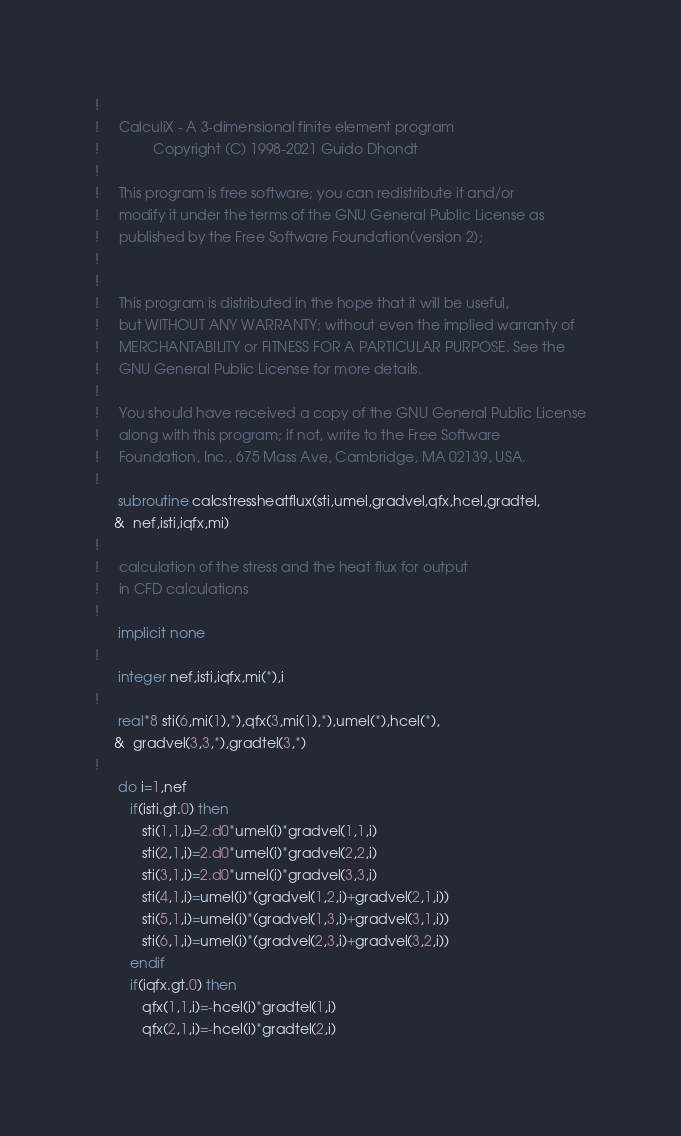Convert code to text. <code><loc_0><loc_0><loc_500><loc_500><_FORTRAN_>!
!     CalculiX - A 3-dimensional finite element program
!              Copyright (C) 1998-2021 Guido Dhondt
!
!     This program is free software; you can redistribute it and/or
!     modify it under the terms of the GNU General Public License as
!     published by the Free Software Foundation(version 2);
!     
!
!     This program is distributed in the hope that it will be useful,
!     but WITHOUT ANY WARRANTY; without even the implied warranty of 
!     MERCHANTABILITY or FITNESS FOR A PARTICULAR PURPOSE. See the 
!     GNU General Public License for more details.
!
!     You should have received a copy of the GNU General Public License
!     along with this program; if not, write to the Free Software
!     Foundation, Inc., 675 Mass Ave, Cambridge, MA 02139, USA.
!
      subroutine calcstressheatflux(sti,umel,gradvel,qfx,hcel,gradtel,
     &  nef,isti,iqfx,mi)
!
!     calculation of the stress and the heat flux for output
!     in CFD calculations
!
      implicit none
!
      integer nef,isti,iqfx,mi(*),i
!
      real*8 sti(6,mi(1),*),qfx(3,mi(1),*),umel(*),hcel(*),
     &  gradvel(3,3,*),gradtel(3,*)
!
      do i=1,nef
         if(isti.gt.0) then
            sti(1,1,i)=2.d0*umel(i)*gradvel(1,1,i)
            sti(2,1,i)=2.d0*umel(i)*gradvel(2,2,i)
            sti(3,1,i)=2.d0*umel(i)*gradvel(3,3,i)
            sti(4,1,i)=umel(i)*(gradvel(1,2,i)+gradvel(2,1,i))
            sti(5,1,i)=umel(i)*(gradvel(1,3,i)+gradvel(3,1,i))
            sti(6,1,i)=umel(i)*(gradvel(2,3,i)+gradvel(3,2,i))
         endif
         if(iqfx.gt.0) then
            qfx(1,1,i)=-hcel(i)*gradtel(1,i)
            qfx(2,1,i)=-hcel(i)*gradtel(2,i)</code> 